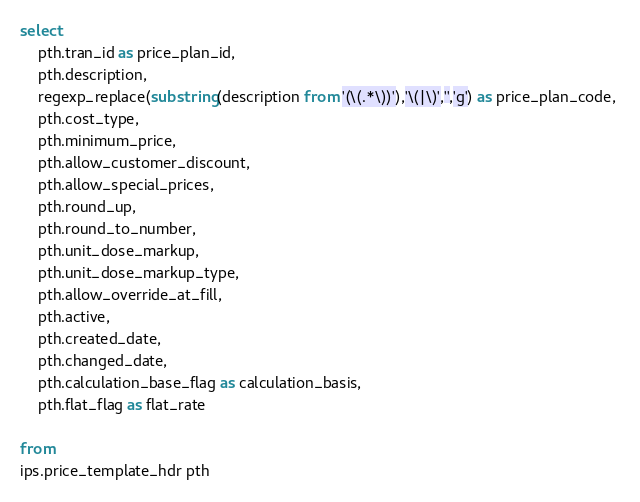Convert code to text. <code><loc_0><loc_0><loc_500><loc_500><_SQL_>select
    pth.tran_id as price_plan_id, 
    pth.description, 
    regexp_replace(substring(description from '(\(.*\))'),'\(|\)','','g') as price_plan_code, 
    pth.cost_type, 
    pth.minimum_price, 
    pth.allow_customer_discount,
    pth.allow_special_prices, 
    pth.round_up, 
    pth.round_to_number, 
    pth.unit_dose_markup, 
    pth.unit_dose_markup_type, 
    pth.allow_override_at_fill, 
    pth.active, 
    pth.created_date, 
    pth.changed_date,
    pth.calculation_base_flag as calculation_basis,
    pth.flat_flag as flat_rate
	
from 
ips.price_template_hdr pth </code> 